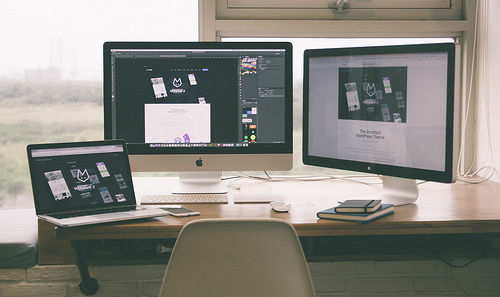<image>
Is the phone on the laptop? No. The phone is not positioned on the laptop. They may be near each other, but the phone is not supported by or resting on top of the laptop. 